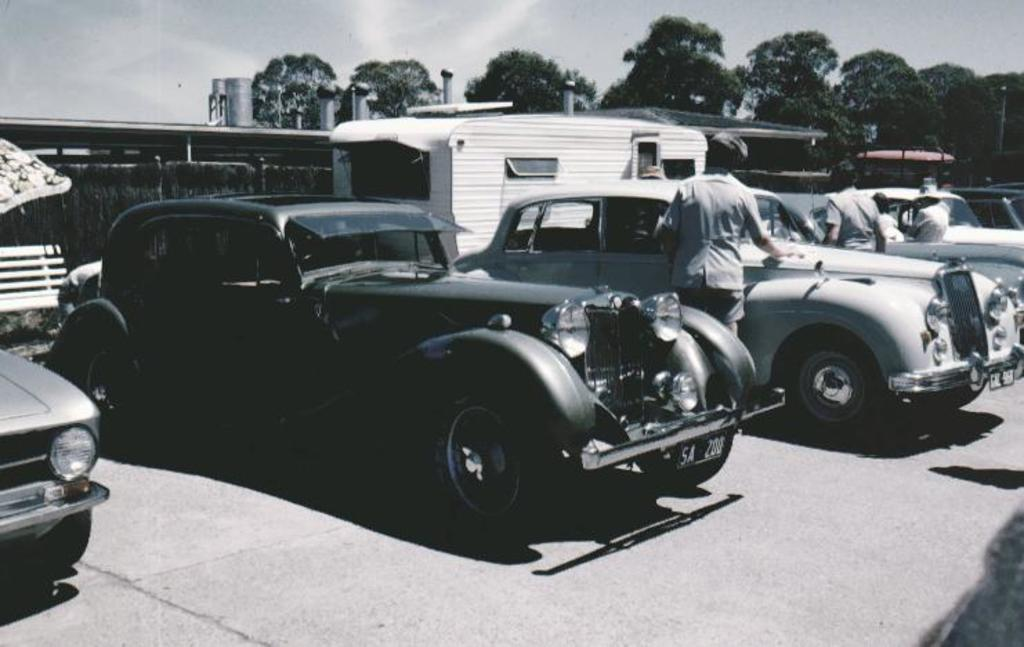What types of vehicles are in the image? There are different color cars in the image. What are the people near the cars doing? Some persons are standing near the cars. What can be seen in the background of the image? There are trees and the sky visible at the top of the image. What type of paste is being used to decorate the cars in the image? There is no paste or decoration visible on the cars in the image. What kind of experience can be gained from observing the cars in the image? The image does not convey any specific experience; it simply shows different color cars with people standing nearby. 